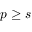Convert formula to latex. <formula><loc_0><loc_0><loc_500><loc_500>p \geq s</formula> 